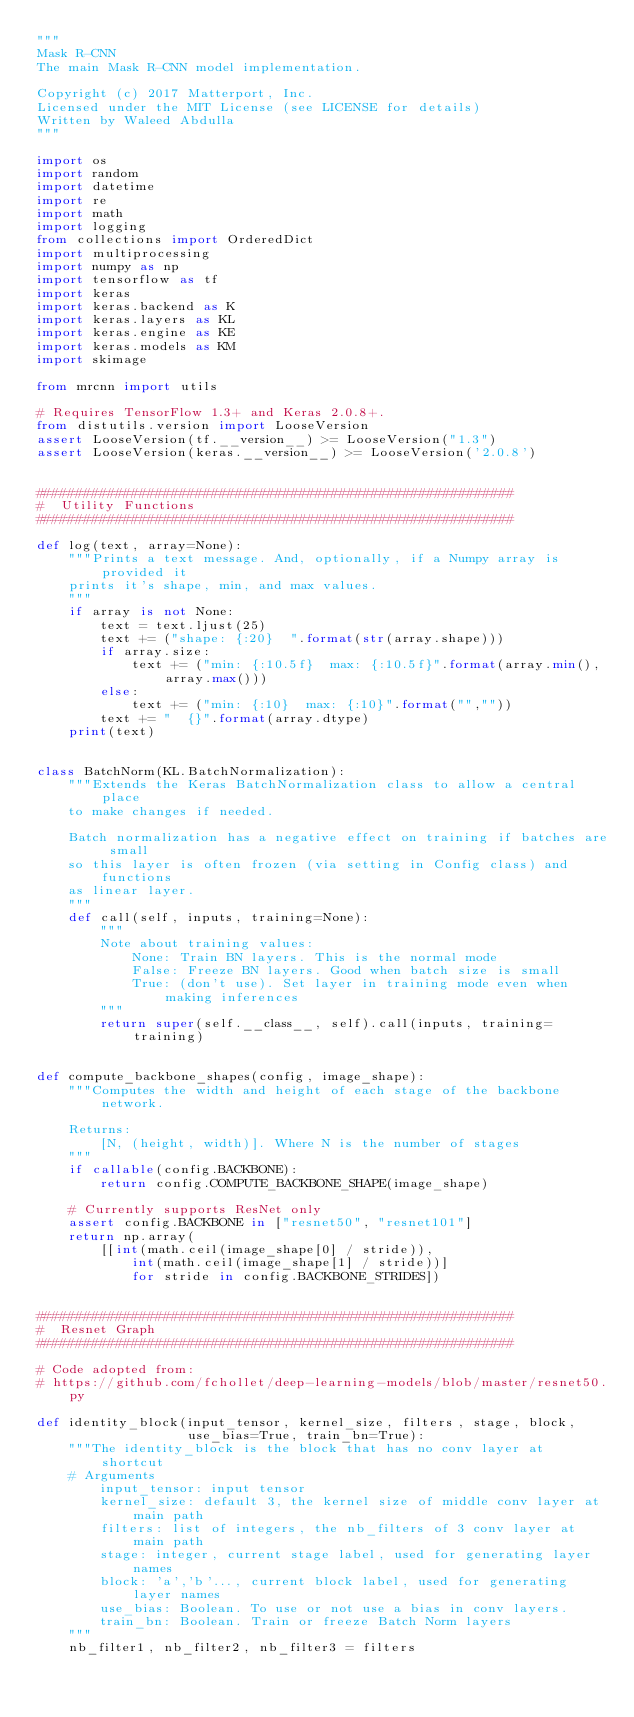<code> <loc_0><loc_0><loc_500><loc_500><_Python_>"""
Mask R-CNN
The main Mask R-CNN model implementation.

Copyright (c) 2017 Matterport, Inc.
Licensed under the MIT License (see LICENSE for details)
Written by Waleed Abdulla
"""

import os
import random
import datetime
import re
import math
import logging
from collections import OrderedDict
import multiprocessing
import numpy as np
import tensorflow as tf
import keras
import keras.backend as K
import keras.layers as KL
import keras.engine as KE
import keras.models as KM
import skimage

from mrcnn import utils

# Requires TensorFlow 1.3+ and Keras 2.0.8+.
from distutils.version import LooseVersion
assert LooseVersion(tf.__version__) >= LooseVersion("1.3")
assert LooseVersion(keras.__version__) >= LooseVersion('2.0.8')


############################################################
#  Utility Functions
############################################################

def log(text, array=None):
    """Prints a text message. And, optionally, if a Numpy array is provided it
    prints it's shape, min, and max values.
    """
    if array is not None:
        text = text.ljust(25)
        text += ("shape: {:20}  ".format(str(array.shape)))
        if array.size:
            text += ("min: {:10.5f}  max: {:10.5f}".format(array.min(),array.max()))
        else:
            text += ("min: {:10}  max: {:10}".format("",""))
        text += "  {}".format(array.dtype)
    print(text)


class BatchNorm(KL.BatchNormalization):
    """Extends the Keras BatchNormalization class to allow a central place
    to make changes if needed.

    Batch normalization has a negative effect on training if batches are small
    so this layer is often frozen (via setting in Config class) and functions
    as linear layer.
    """
    def call(self, inputs, training=None):
        """
        Note about training values:
            None: Train BN layers. This is the normal mode
            False: Freeze BN layers. Good when batch size is small
            True: (don't use). Set layer in training mode even when making inferences
        """
        return super(self.__class__, self).call(inputs, training=training)


def compute_backbone_shapes(config, image_shape):
    """Computes the width and height of each stage of the backbone network.

    Returns:
        [N, (height, width)]. Where N is the number of stages
    """
    if callable(config.BACKBONE):
        return config.COMPUTE_BACKBONE_SHAPE(image_shape)

    # Currently supports ResNet only
    assert config.BACKBONE in ["resnet50", "resnet101"]
    return np.array(
        [[int(math.ceil(image_shape[0] / stride)),
            int(math.ceil(image_shape[1] / stride))]
            for stride in config.BACKBONE_STRIDES])


############################################################
#  Resnet Graph
############################################################

# Code adopted from:
# https://github.com/fchollet/deep-learning-models/blob/master/resnet50.py

def identity_block(input_tensor, kernel_size, filters, stage, block,
                   use_bias=True, train_bn=True):
    """The identity_block is the block that has no conv layer at shortcut
    # Arguments
        input_tensor: input tensor
        kernel_size: default 3, the kernel size of middle conv layer at main path
        filters: list of integers, the nb_filters of 3 conv layer at main path
        stage: integer, current stage label, used for generating layer names
        block: 'a','b'..., current block label, used for generating layer names
        use_bias: Boolean. To use or not use a bias in conv layers.
        train_bn: Boolean. Train or freeze Batch Norm layers
    """
    nb_filter1, nb_filter2, nb_filter3 = filters</code> 